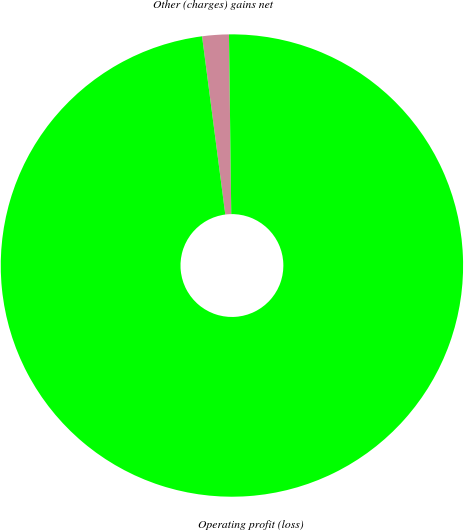Convert chart to OTSL. <chart><loc_0><loc_0><loc_500><loc_500><pie_chart><fcel>Other (charges) gains net<fcel>Operating profit (loss)<nl><fcel>1.86%<fcel>98.14%<nl></chart> 